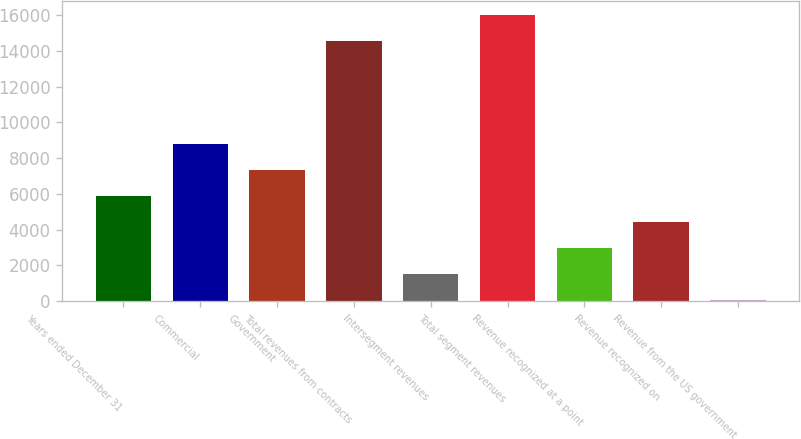<chart> <loc_0><loc_0><loc_500><loc_500><bar_chart><fcel>Years ended December 31<fcel>Commercial<fcel>Government<fcel>Total revenues from contracts<fcel>Intersegment revenues<fcel>Total segment revenues<fcel>Revenue recognized at a point<fcel>Revenue recognized on<fcel>Revenue from the US government<nl><fcel>5855.8<fcel>8764.2<fcel>7310<fcel>14532<fcel>1493.2<fcel>15986.2<fcel>2947.4<fcel>4401.6<fcel>39<nl></chart> 